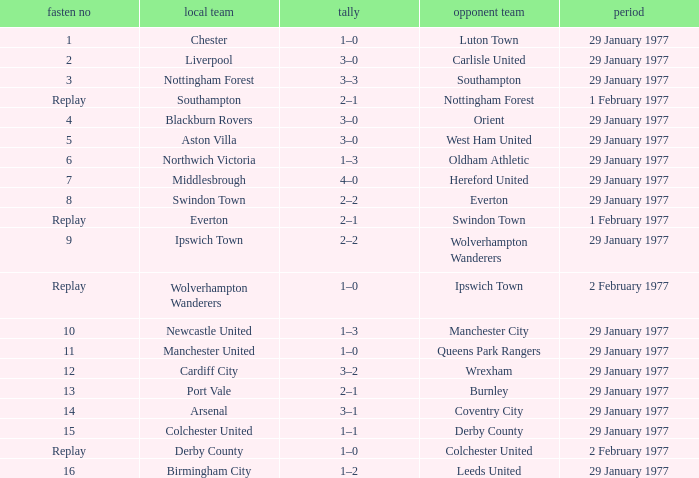Which away team has a tie number of 3? Southampton. 